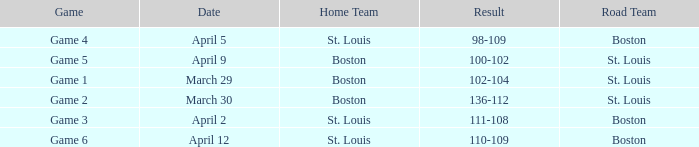What is the Result of the Game on April 9? 100-102. 